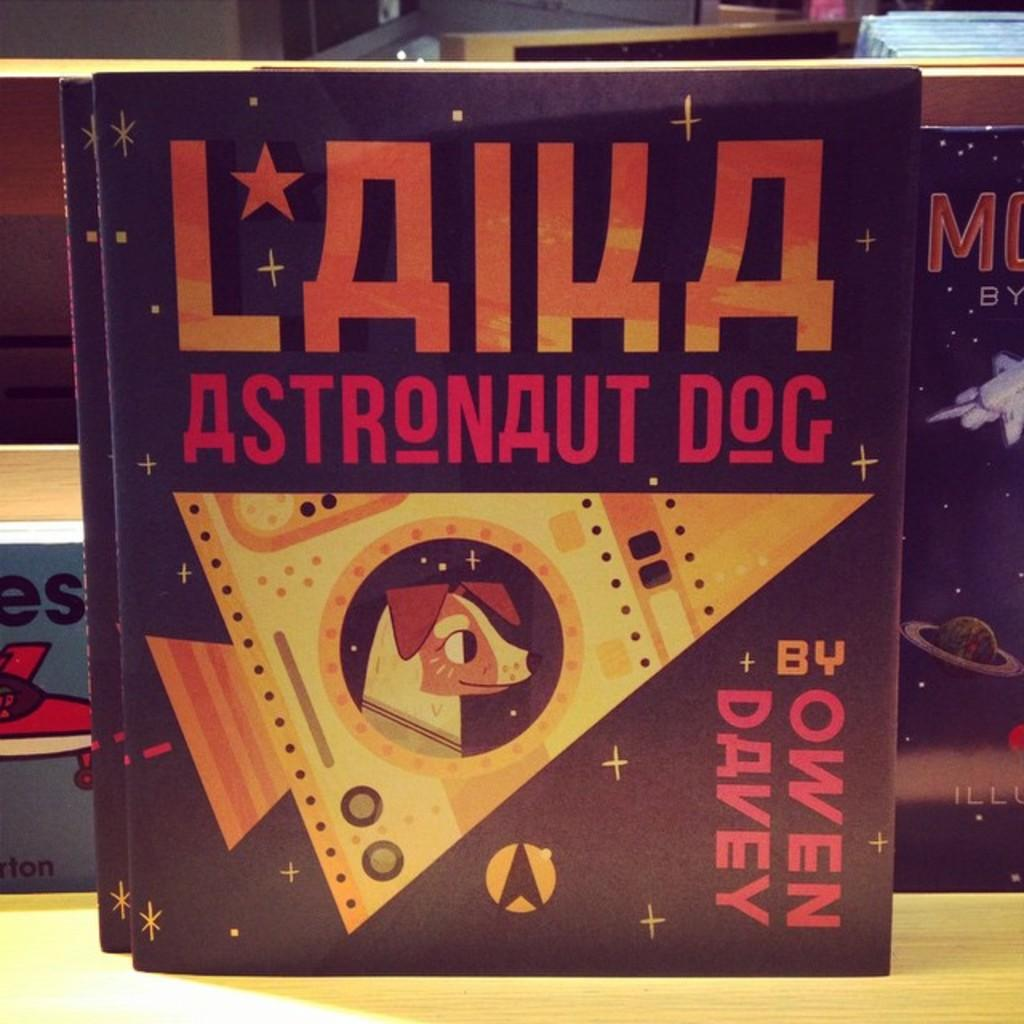<image>
Offer a succinct explanation of the picture presented. The book Laika, astronaut dog written by Owen Davey. 